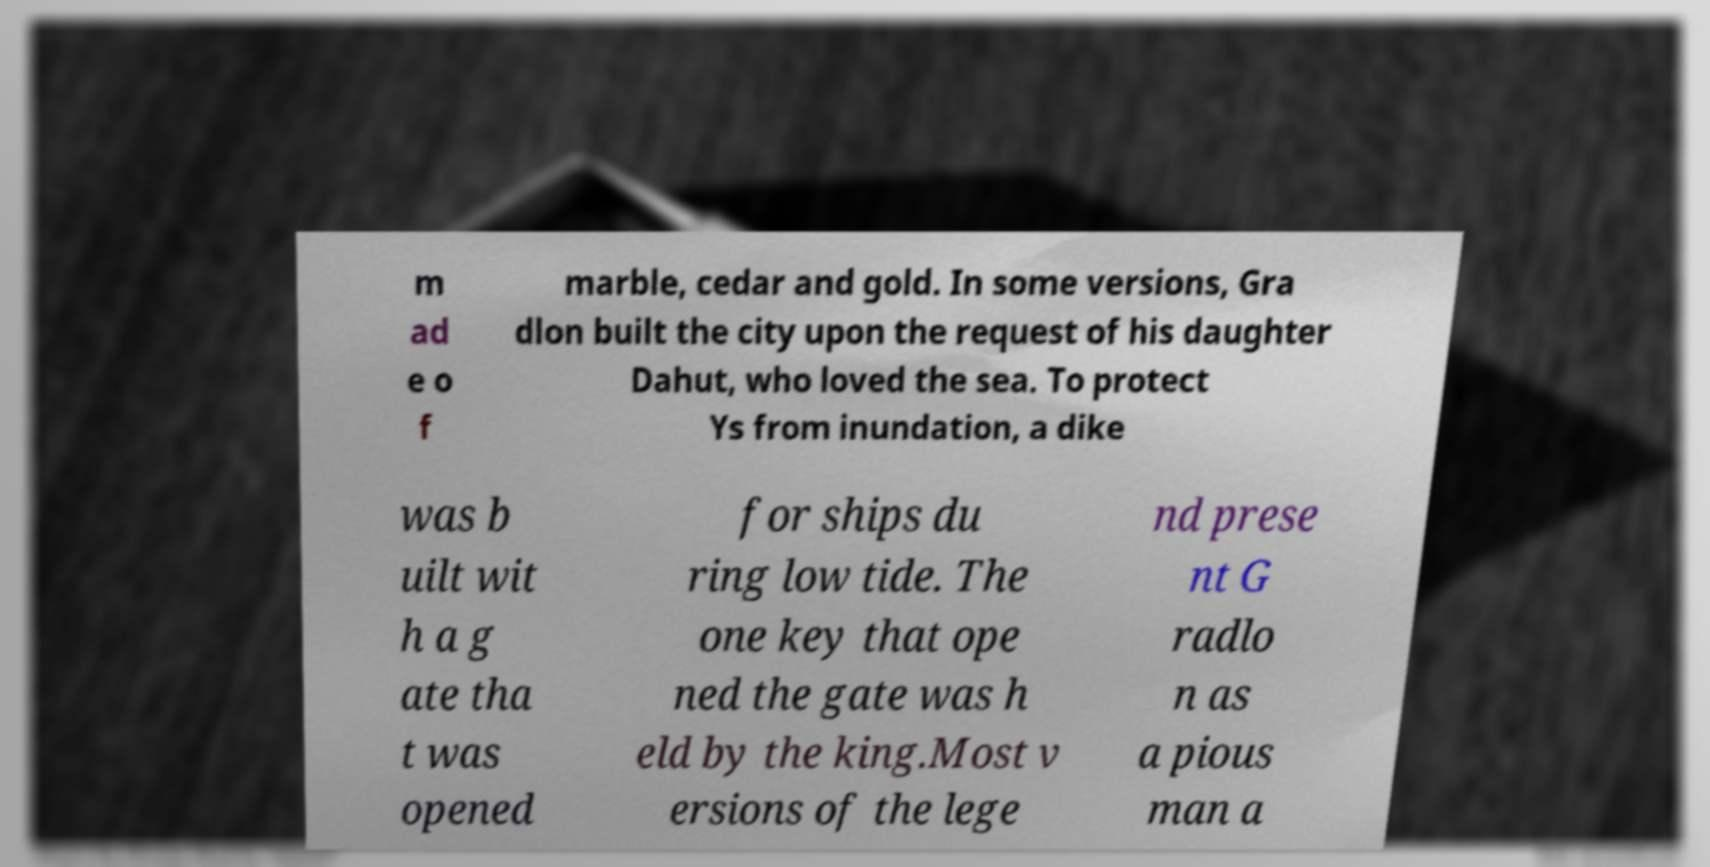What messages or text are displayed in this image? I need them in a readable, typed format. m ad e o f marble, cedar and gold. In some versions, Gra dlon built the city upon the request of his daughter Dahut, who loved the sea. To protect Ys from inundation, a dike was b uilt wit h a g ate tha t was opened for ships du ring low tide. The one key that ope ned the gate was h eld by the king.Most v ersions of the lege nd prese nt G radlo n as a pious man a 